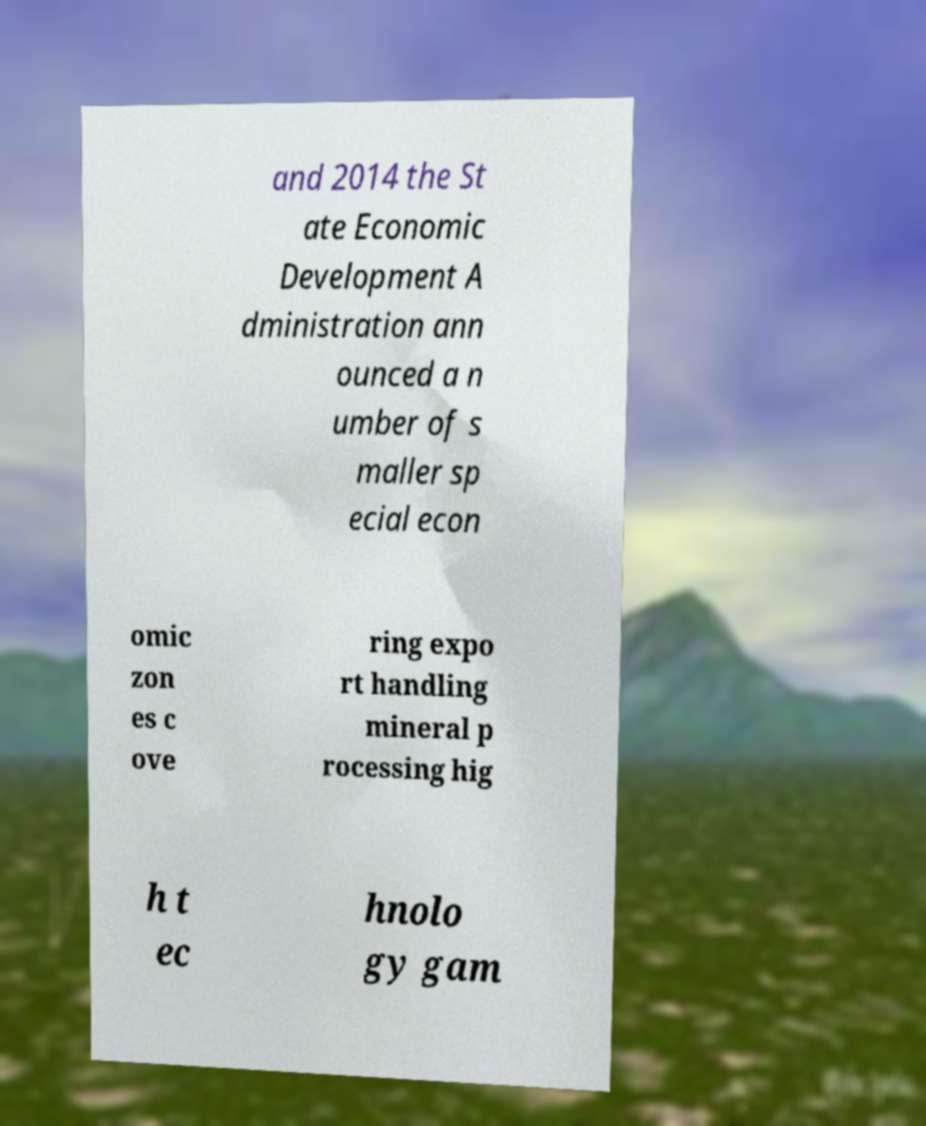Can you read and provide the text displayed in the image?This photo seems to have some interesting text. Can you extract and type it out for me? and 2014 the St ate Economic Development A dministration ann ounced a n umber of s maller sp ecial econ omic zon es c ove ring expo rt handling mineral p rocessing hig h t ec hnolo gy gam 